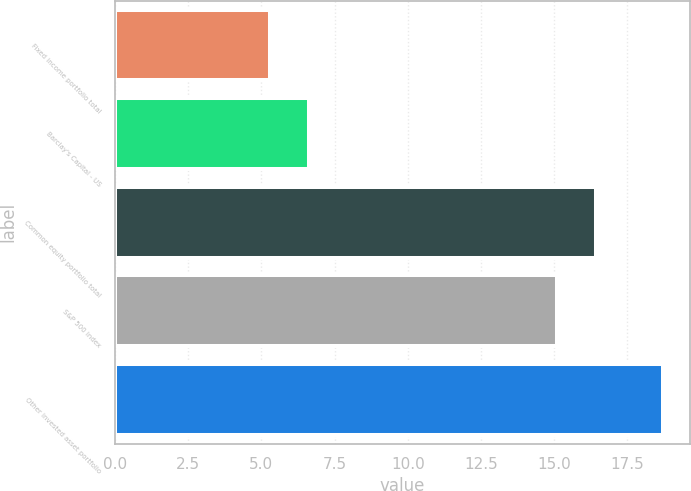Convert chart to OTSL. <chart><loc_0><loc_0><loc_500><loc_500><bar_chart><fcel>Fixed income portfolio total<fcel>Barclay's Capital - US<fcel>Common equity portfolio total<fcel>S&P 500 index<fcel>Other invested asset portfolio<nl><fcel>5.3<fcel>6.64<fcel>16.44<fcel>15.1<fcel>18.7<nl></chart> 